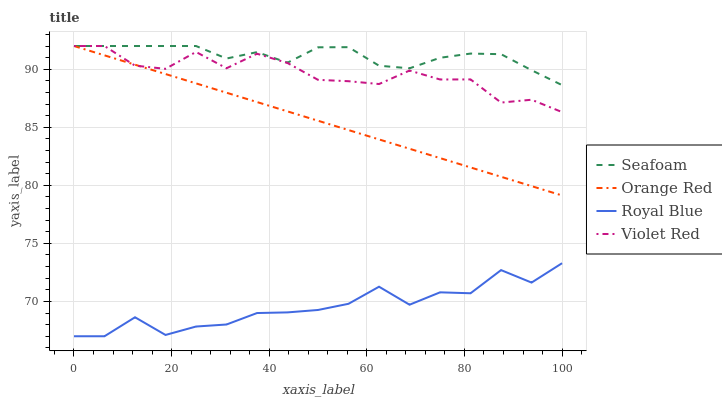Does Royal Blue have the minimum area under the curve?
Answer yes or no. Yes. Does Seafoam have the maximum area under the curve?
Answer yes or no. Yes. Does Violet Red have the minimum area under the curve?
Answer yes or no. No. Does Violet Red have the maximum area under the curve?
Answer yes or no. No. Is Orange Red the smoothest?
Answer yes or no. Yes. Is Royal Blue the roughest?
Answer yes or no. Yes. Is Violet Red the smoothest?
Answer yes or no. No. Is Violet Red the roughest?
Answer yes or no. No. Does Royal Blue have the lowest value?
Answer yes or no. Yes. Does Violet Red have the lowest value?
Answer yes or no. No. Does Orange Red have the highest value?
Answer yes or no. Yes. Is Royal Blue less than Seafoam?
Answer yes or no. Yes. Is Violet Red greater than Royal Blue?
Answer yes or no. Yes. Does Seafoam intersect Orange Red?
Answer yes or no. Yes. Is Seafoam less than Orange Red?
Answer yes or no. No. Is Seafoam greater than Orange Red?
Answer yes or no. No. Does Royal Blue intersect Seafoam?
Answer yes or no. No. 